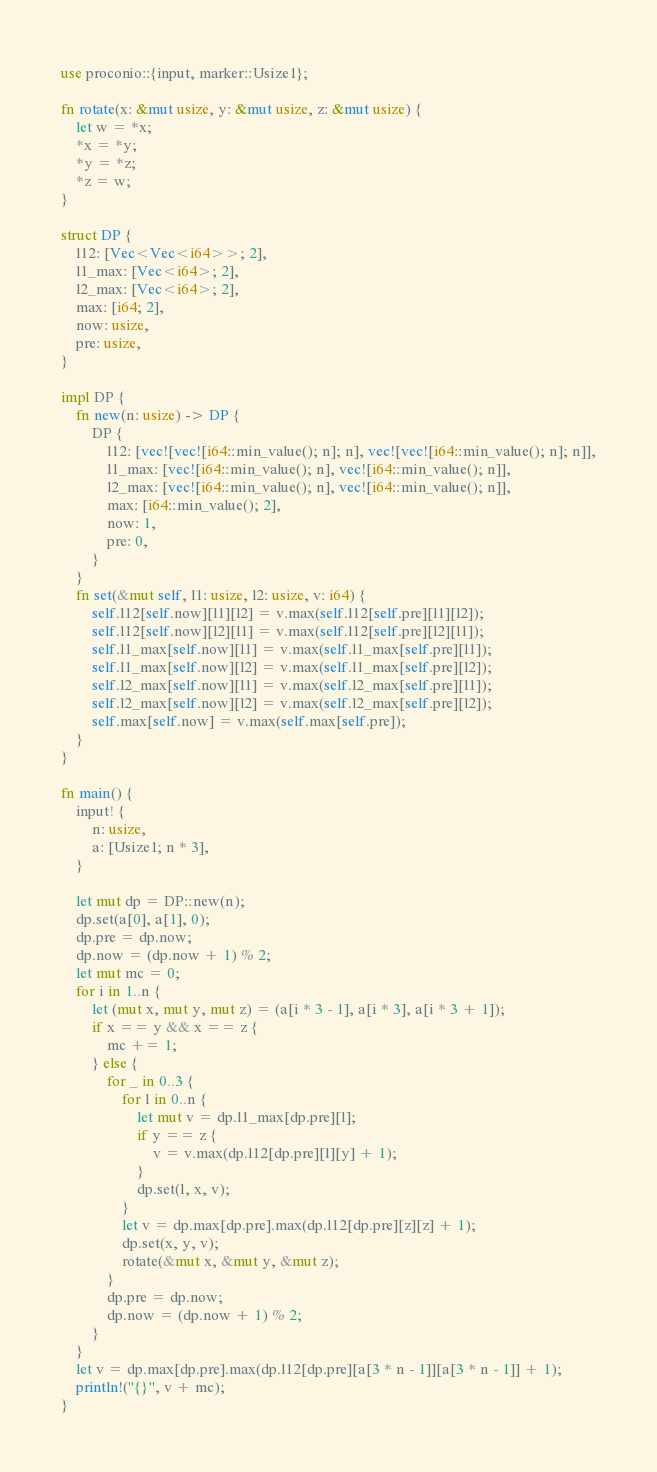Convert code to text. <code><loc_0><loc_0><loc_500><loc_500><_Rust_>use proconio::{input, marker::Usize1};

fn rotate(x: &mut usize, y: &mut usize, z: &mut usize) {
    let w = *x;
    *x = *y;
    *y = *z;
    *z = w;
}

struct DP {
    l12: [Vec<Vec<i64>>; 2],
    l1_max: [Vec<i64>; 2],
    l2_max: [Vec<i64>; 2],
    max: [i64; 2],
    now: usize,
    pre: usize,
}

impl DP {
    fn new(n: usize) -> DP {
        DP {
            l12: [vec![vec![i64::min_value(); n]; n], vec![vec![i64::min_value(); n]; n]],
            l1_max: [vec![i64::min_value(); n], vec![i64::min_value(); n]],
            l2_max: [vec![i64::min_value(); n], vec![i64::min_value(); n]],
            max: [i64::min_value(); 2],
            now: 1,
            pre: 0,
        }
    }
    fn set(&mut self, l1: usize, l2: usize, v: i64) {
        self.l12[self.now][l1][l2] = v.max(self.l12[self.pre][l1][l2]);
        self.l12[self.now][l2][l1] = v.max(self.l12[self.pre][l2][l1]);
        self.l1_max[self.now][l1] = v.max(self.l1_max[self.pre][l1]);
        self.l1_max[self.now][l2] = v.max(self.l1_max[self.pre][l2]);
        self.l2_max[self.now][l1] = v.max(self.l2_max[self.pre][l1]);
        self.l2_max[self.now][l2] = v.max(self.l2_max[self.pre][l2]);
        self.max[self.now] = v.max(self.max[self.pre]);
    }
}

fn main() {
    input! {
        n: usize,
        a: [Usize1; n * 3],
    }

    let mut dp = DP::new(n);
    dp.set(a[0], a[1], 0);
    dp.pre = dp.now;
    dp.now = (dp.now + 1) % 2;
    let mut mc = 0;
    for i in 1..n {
        let (mut x, mut y, mut z) = (a[i * 3 - 1], a[i * 3], a[i * 3 + 1]);
        if x == y && x == z {
            mc += 1;
        } else {
            for _ in 0..3 {
                for l in 0..n {
                    let mut v = dp.l1_max[dp.pre][l];
                    if y == z {
                        v = v.max(dp.l12[dp.pre][l][y] + 1);
                    }
                    dp.set(l, x, v);
                }
                let v = dp.max[dp.pre].max(dp.l12[dp.pre][z][z] + 1);
                dp.set(x, y, v);
                rotate(&mut x, &mut y, &mut z);
            }
            dp.pre = dp.now;
            dp.now = (dp.now + 1) % 2;
        }
    }
    let v = dp.max[dp.pre].max(dp.l12[dp.pre][a[3 * n - 1]][a[3 * n - 1]] + 1);
    println!("{}", v + mc);
}
</code> 